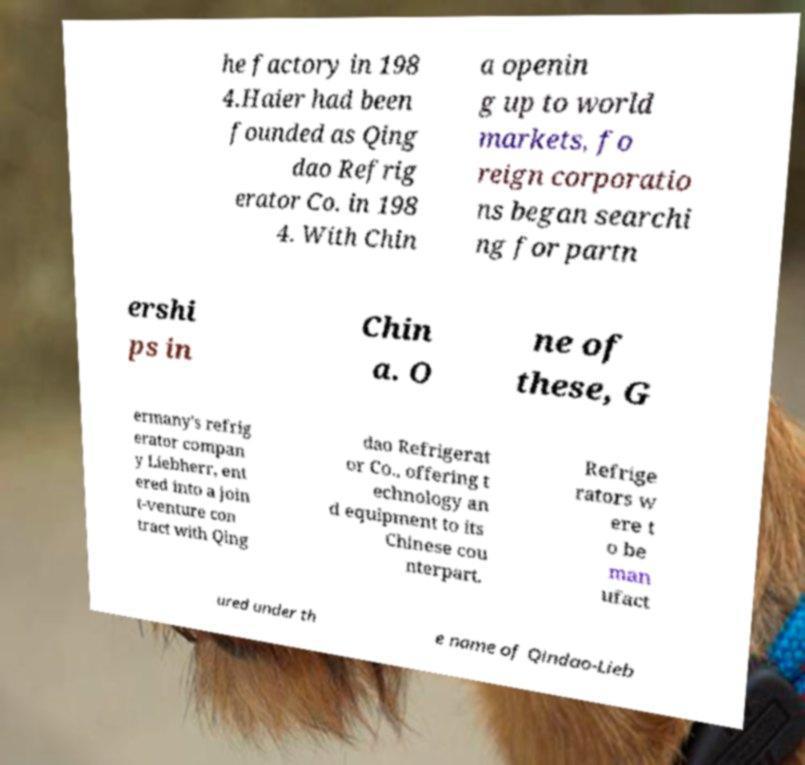Could you assist in decoding the text presented in this image and type it out clearly? he factory in 198 4.Haier had been founded as Qing dao Refrig erator Co. in 198 4. With Chin a openin g up to world markets, fo reign corporatio ns began searchi ng for partn ershi ps in Chin a. O ne of these, G ermany's refrig erator compan y Liebherr, ent ered into a join t-venture con tract with Qing dao Refrigerat or Co., offering t echnology an d equipment to its Chinese cou nterpart. Refrige rators w ere t o be man ufact ured under th e name of Qindao-Lieb 